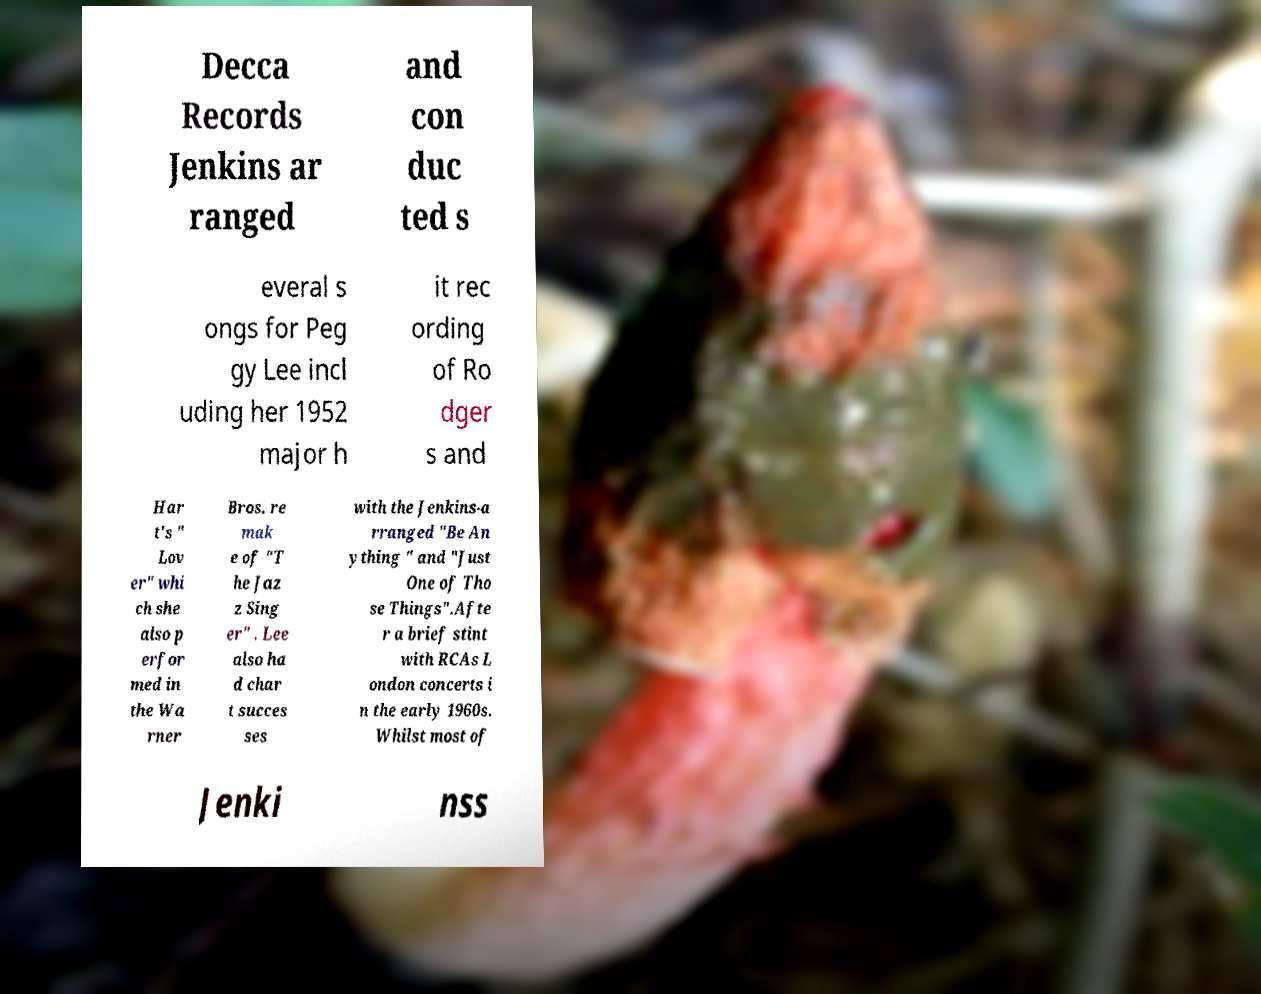There's text embedded in this image that I need extracted. Can you transcribe it verbatim? Decca Records Jenkins ar ranged and con duc ted s everal s ongs for Peg gy Lee incl uding her 1952 major h it rec ording of Ro dger s and Har t's " Lov er" whi ch she also p erfor med in the Wa rner Bros. re mak e of "T he Jaz z Sing er" . Lee also ha d char t succes ses with the Jenkins-a rranged "Be An ything " and "Just One of Tho se Things".Afte r a brief stint with RCAs L ondon concerts i n the early 1960s. Whilst most of Jenki nss 